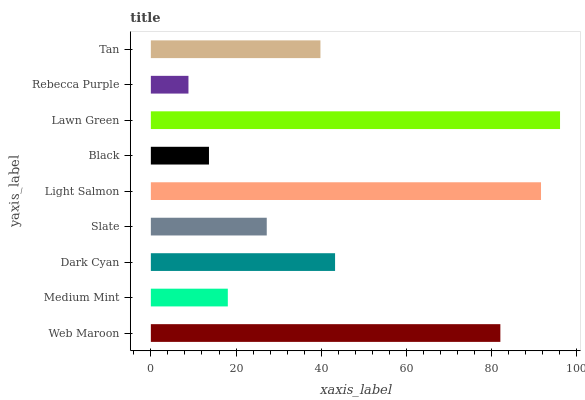Is Rebecca Purple the minimum?
Answer yes or no. Yes. Is Lawn Green the maximum?
Answer yes or no. Yes. Is Medium Mint the minimum?
Answer yes or no. No. Is Medium Mint the maximum?
Answer yes or no. No. Is Web Maroon greater than Medium Mint?
Answer yes or no. Yes. Is Medium Mint less than Web Maroon?
Answer yes or no. Yes. Is Medium Mint greater than Web Maroon?
Answer yes or no. No. Is Web Maroon less than Medium Mint?
Answer yes or no. No. Is Tan the high median?
Answer yes or no. Yes. Is Tan the low median?
Answer yes or no. Yes. Is Light Salmon the high median?
Answer yes or no. No. Is Medium Mint the low median?
Answer yes or no. No. 